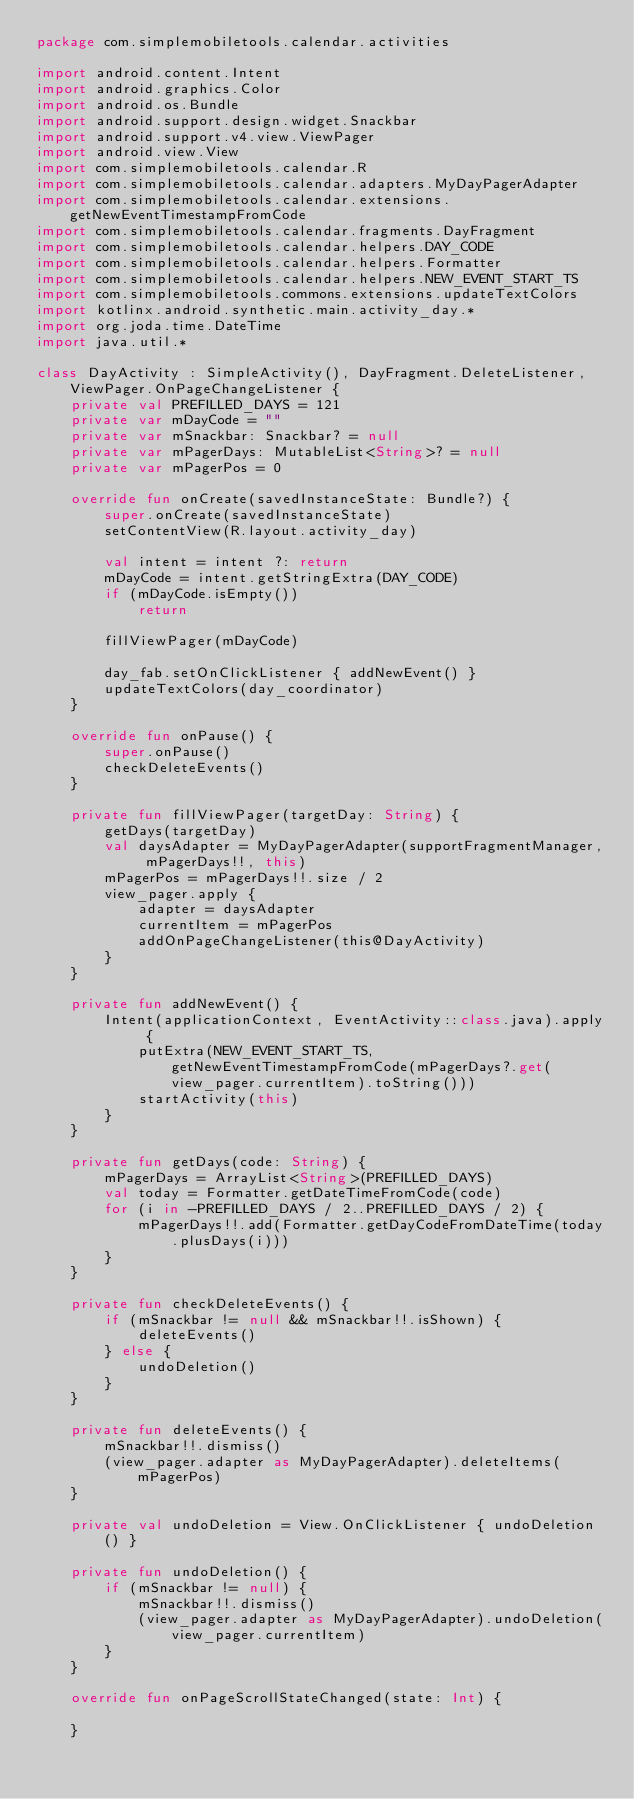<code> <loc_0><loc_0><loc_500><loc_500><_Kotlin_>package com.simplemobiletools.calendar.activities

import android.content.Intent
import android.graphics.Color
import android.os.Bundle
import android.support.design.widget.Snackbar
import android.support.v4.view.ViewPager
import android.view.View
import com.simplemobiletools.calendar.R
import com.simplemobiletools.calendar.adapters.MyDayPagerAdapter
import com.simplemobiletools.calendar.extensions.getNewEventTimestampFromCode
import com.simplemobiletools.calendar.fragments.DayFragment
import com.simplemobiletools.calendar.helpers.DAY_CODE
import com.simplemobiletools.calendar.helpers.Formatter
import com.simplemobiletools.calendar.helpers.NEW_EVENT_START_TS
import com.simplemobiletools.commons.extensions.updateTextColors
import kotlinx.android.synthetic.main.activity_day.*
import org.joda.time.DateTime
import java.util.*

class DayActivity : SimpleActivity(), DayFragment.DeleteListener, ViewPager.OnPageChangeListener {
    private val PREFILLED_DAYS = 121
    private var mDayCode = ""
    private var mSnackbar: Snackbar? = null
    private var mPagerDays: MutableList<String>? = null
    private var mPagerPos = 0

    override fun onCreate(savedInstanceState: Bundle?) {
        super.onCreate(savedInstanceState)
        setContentView(R.layout.activity_day)

        val intent = intent ?: return
        mDayCode = intent.getStringExtra(DAY_CODE)
        if (mDayCode.isEmpty())
            return

        fillViewPager(mDayCode)

        day_fab.setOnClickListener { addNewEvent() }
        updateTextColors(day_coordinator)
    }

    override fun onPause() {
        super.onPause()
        checkDeleteEvents()
    }

    private fun fillViewPager(targetDay: String) {
        getDays(targetDay)
        val daysAdapter = MyDayPagerAdapter(supportFragmentManager, mPagerDays!!, this)
        mPagerPos = mPagerDays!!.size / 2
        view_pager.apply {
            adapter = daysAdapter
            currentItem = mPagerPos
            addOnPageChangeListener(this@DayActivity)
        }
    }

    private fun addNewEvent() {
        Intent(applicationContext, EventActivity::class.java).apply {
            putExtra(NEW_EVENT_START_TS, getNewEventTimestampFromCode(mPagerDays?.get(view_pager.currentItem).toString()))
            startActivity(this)
        }
    }

    private fun getDays(code: String) {
        mPagerDays = ArrayList<String>(PREFILLED_DAYS)
        val today = Formatter.getDateTimeFromCode(code)
        for (i in -PREFILLED_DAYS / 2..PREFILLED_DAYS / 2) {
            mPagerDays!!.add(Formatter.getDayCodeFromDateTime(today.plusDays(i)))
        }
    }

    private fun checkDeleteEvents() {
        if (mSnackbar != null && mSnackbar!!.isShown) {
            deleteEvents()
        } else {
            undoDeletion()
        }
    }

    private fun deleteEvents() {
        mSnackbar!!.dismiss()
        (view_pager.adapter as MyDayPagerAdapter).deleteItems(mPagerPos)
    }

    private val undoDeletion = View.OnClickListener { undoDeletion() }

    private fun undoDeletion() {
        if (mSnackbar != null) {
            mSnackbar!!.dismiss()
            (view_pager.adapter as MyDayPagerAdapter).undoDeletion(view_pager.currentItem)
        }
    }

    override fun onPageScrollStateChanged(state: Int) {

    }
</code> 